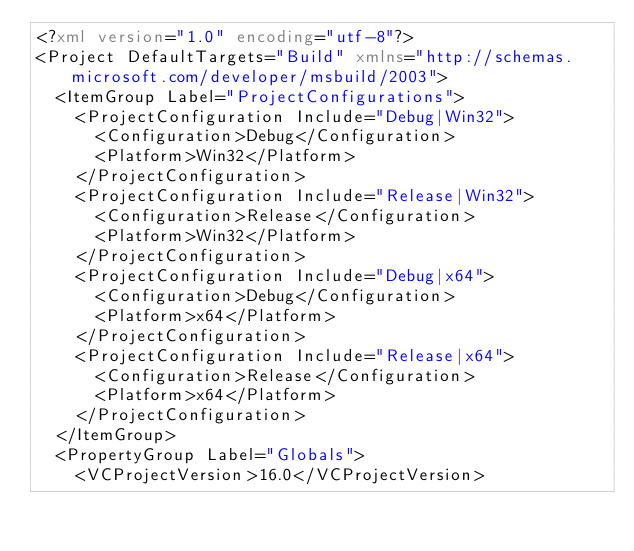Convert code to text. <code><loc_0><loc_0><loc_500><loc_500><_XML_><?xml version="1.0" encoding="utf-8"?>
<Project DefaultTargets="Build" xmlns="http://schemas.microsoft.com/developer/msbuild/2003">
  <ItemGroup Label="ProjectConfigurations">
    <ProjectConfiguration Include="Debug|Win32">
      <Configuration>Debug</Configuration>
      <Platform>Win32</Platform>
    </ProjectConfiguration>
    <ProjectConfiguration Include="Release|Win32">
      <Configuration>Release</Configuration>
      <Platform>Win32</Platform>
    </ProjectConfiguration>
    <ProjectConfiguration Include="Debug|x64">
      <Configuration>Debug</Configuration>
      <Platform>x64</Platform>
    </ProjectConfiguration>
    <ProjectConfiguration Include="Release|x64">
      <Configuration>Release</Configuration>
      <Platform>x64</Platform>
    </ProjectConfiguration>
  </ItemGroup>
  <PropertyGroup Label="Globals">
    <VCProjectVersion>16.0</VCProjectVersion></code> 